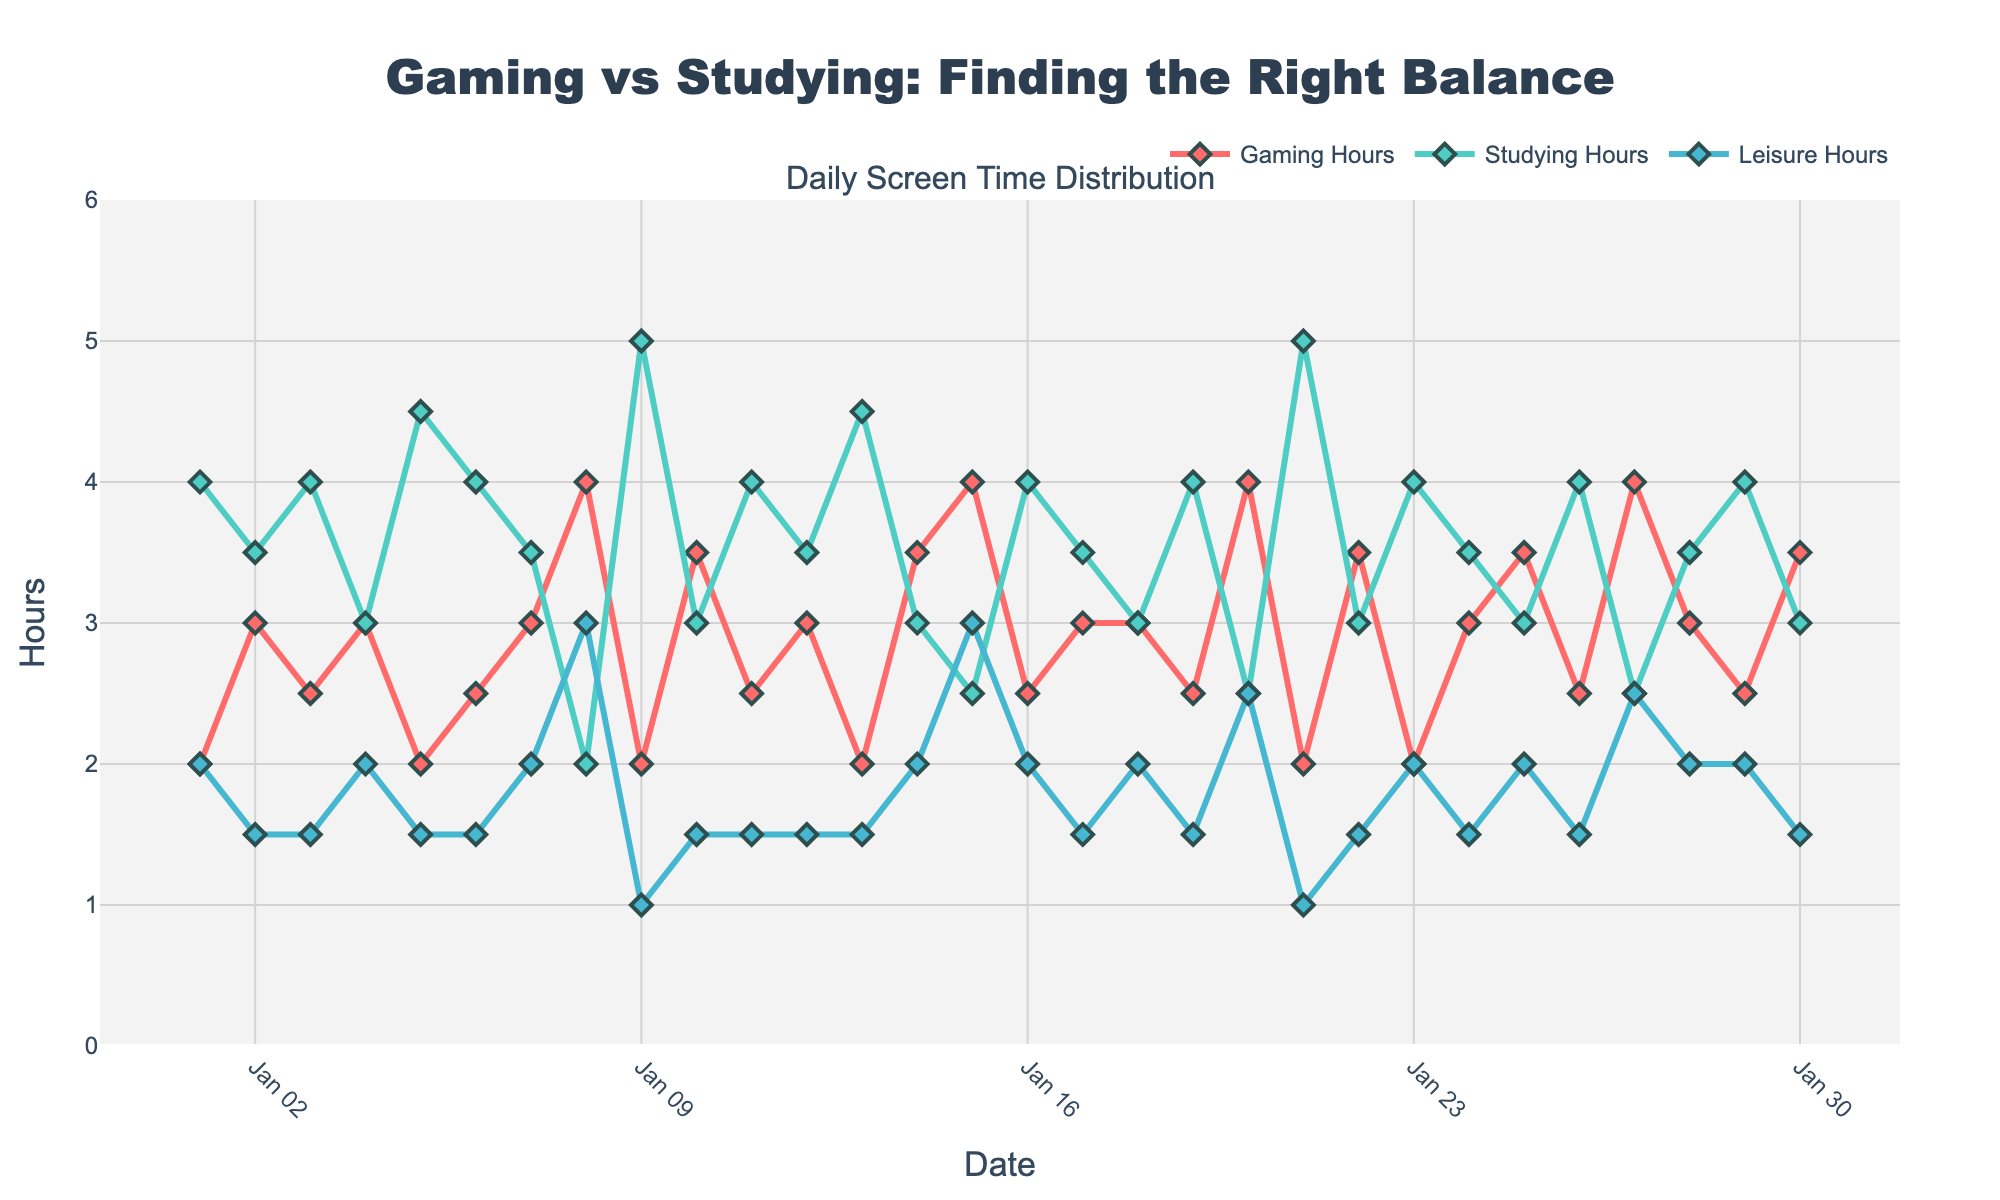What is the title of the figure? Look at the top of the figure where the title is clearly displayed. It reads "Gaming vs Studying: Finding the Right Balance".
Answer: "Gaming vs Studying: Finding the Right Balance" What does the y-axis represent? The y-axis shows the hours spent per day on different activities. This is evident from the label on the y-axis which reads "Hours".
Answer: Hours Which activity has the highest average daily screen time? Calculate the average for each activity (gaming, studying, leisure) by summing the data points and dividing by the number of entries. From a visual check, "studying_hours" appears consistently higher.
Answer: Studying Which date had the highest screen time for gaming? Identify the peak points in the red line (Gaming Hours). January 8, 15, and 27 had the highest gaming screen time, all reaching 4 hours.
Answer: January 8, 15, 27 How does the total amount of screen time compare on January 3 and January 21? Sum the screen time across "gaming_hours," "studying_hours," and "leisure_hours" for each date. January 3 totals 2.5 + 4 + 1.5 = 8 hours, while January 21 totals 2 + 5 + 1 = 8 hours. Both dates have equal total screen time.
Answer: Equal Is there any activity where the screen time is relatively constant? Examine the trend lines for flatness. Of the three categories, "leisure_hours" shows the least variability and is relatively constant around 1.5 to 2 hours.
Answer: Leisure What is the general trend for studying hours? Visually trace the line representing studying hours. The green line indicates a generally high and consistent screen time, around 3.5 to 4 hours, without any large peaks or dips.
Answer: Consistent On which date did gamers spend less than 2.5 hours on gaming and more than 4 hours on studying? Identify the dates where the gaming hours are less than 2.5 and studying hours are more than 4. This is the case on January 9, January 13, and January 21.
Answer: January 9, 13, 21 